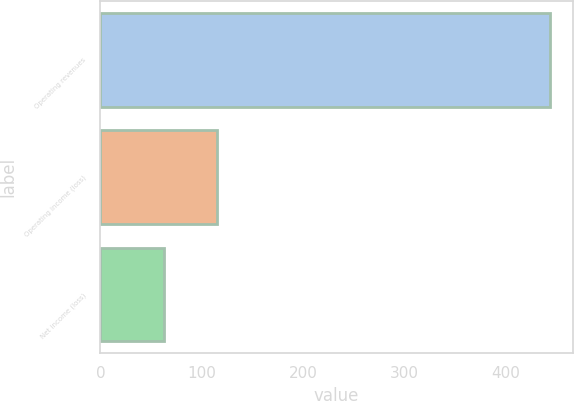<chart> <loc_0><loc_0><loc_500><loc_500><bar_chart><fcel>Operating revenues<fcel>Operating income (loss)<fcel>Net income (loss)<nl><fcel>444<fcel>115<fcel>63<nl></chart> 